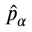Convert formula to latex. <formula><loc_0><loc_0><loc_500><loc_500>\hat { p } _ { \alpha }</formula> 